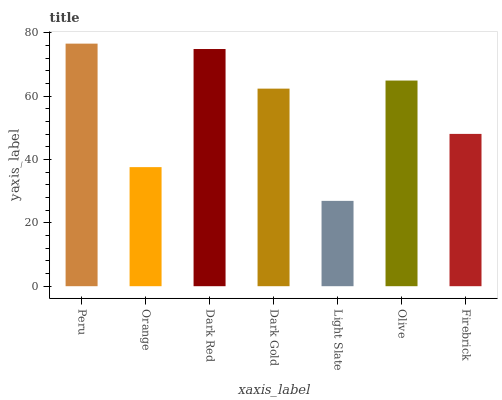Is Light Slate the minimum?
Answer yes or no. Yes. Is Peru the maximum?
Answer yes or no. Yes. Is Orange the minimum?
Answer yes or no. No. Is Orange the maximum?
Answer yes or no. No. Is Peru greater than Orange?
Answer yes or no. Yes. Is Orange less than Peru?
Answer yes or no. Yes. Is Orange greater than Peru?
Answer yes or no. No. Is Peru less than Orange?
Answer yes or no. No. Is Dark Gold the high median?
Answer yes or no. Yes. Is Dark Gold the low median?
Answer yes or no. Yes. Is Firebrick the high median?
Answer yes or no. No. Is Olive the low median?
Answer yes or no. No. 